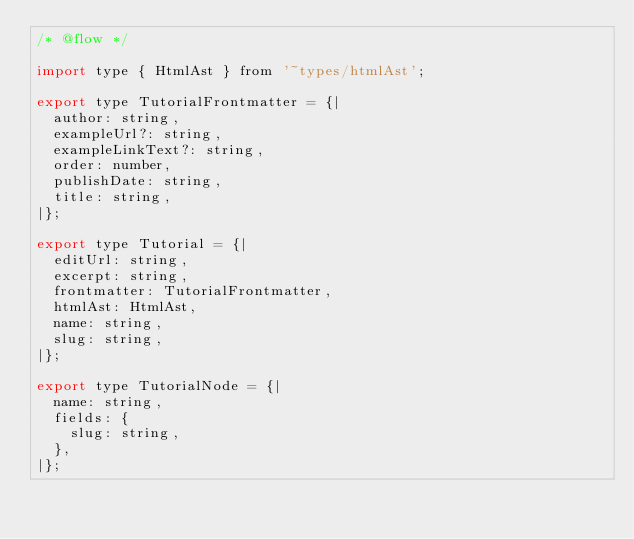Convert code to text. <code><loc_0><loc_0><loc_500><loc_500><_JavaScript_>/* @flow */

import type { HtmlAst } from '~types/htmlAst';

export type TutorialFrontmatter = {|
  author: string,
  exampleUrl?: string,
  exampleLinkText?: string,
  order: number,
  publishDate: string,
  title: string,
|};

export type Tutorial = {|
  editUrl: string,
  excerpt: string,
  frontmatter: TutorialFrontmatter,
  htmlAst: HtmlAst,
  name: string,
  slug: string,
|};

export type TutorialNode = {|
  name: string,
  fields: {
    slug: string,
  },
|};
</code> 